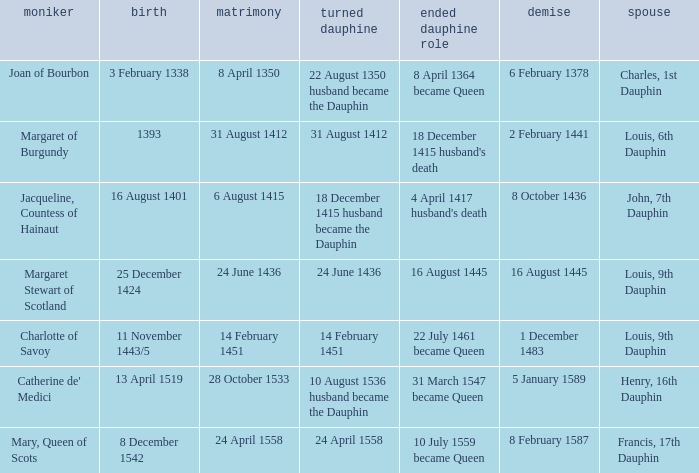When was the death of the person with husband charles, 1st dauphin? 6 February 1378. 